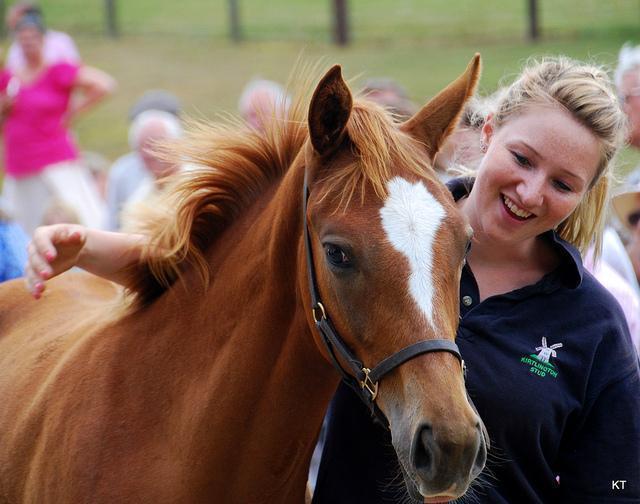How many people can be seen?
Give a very brief answer. 7. 